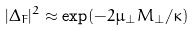<formula> <loc_0><loc_0><loc_500><loc_500>| \Delta _ { F } | ^ { 2 } \approx \exp ( - 2 \mu _ { \perp } M _ { \perp } / \kappa )</formula> 